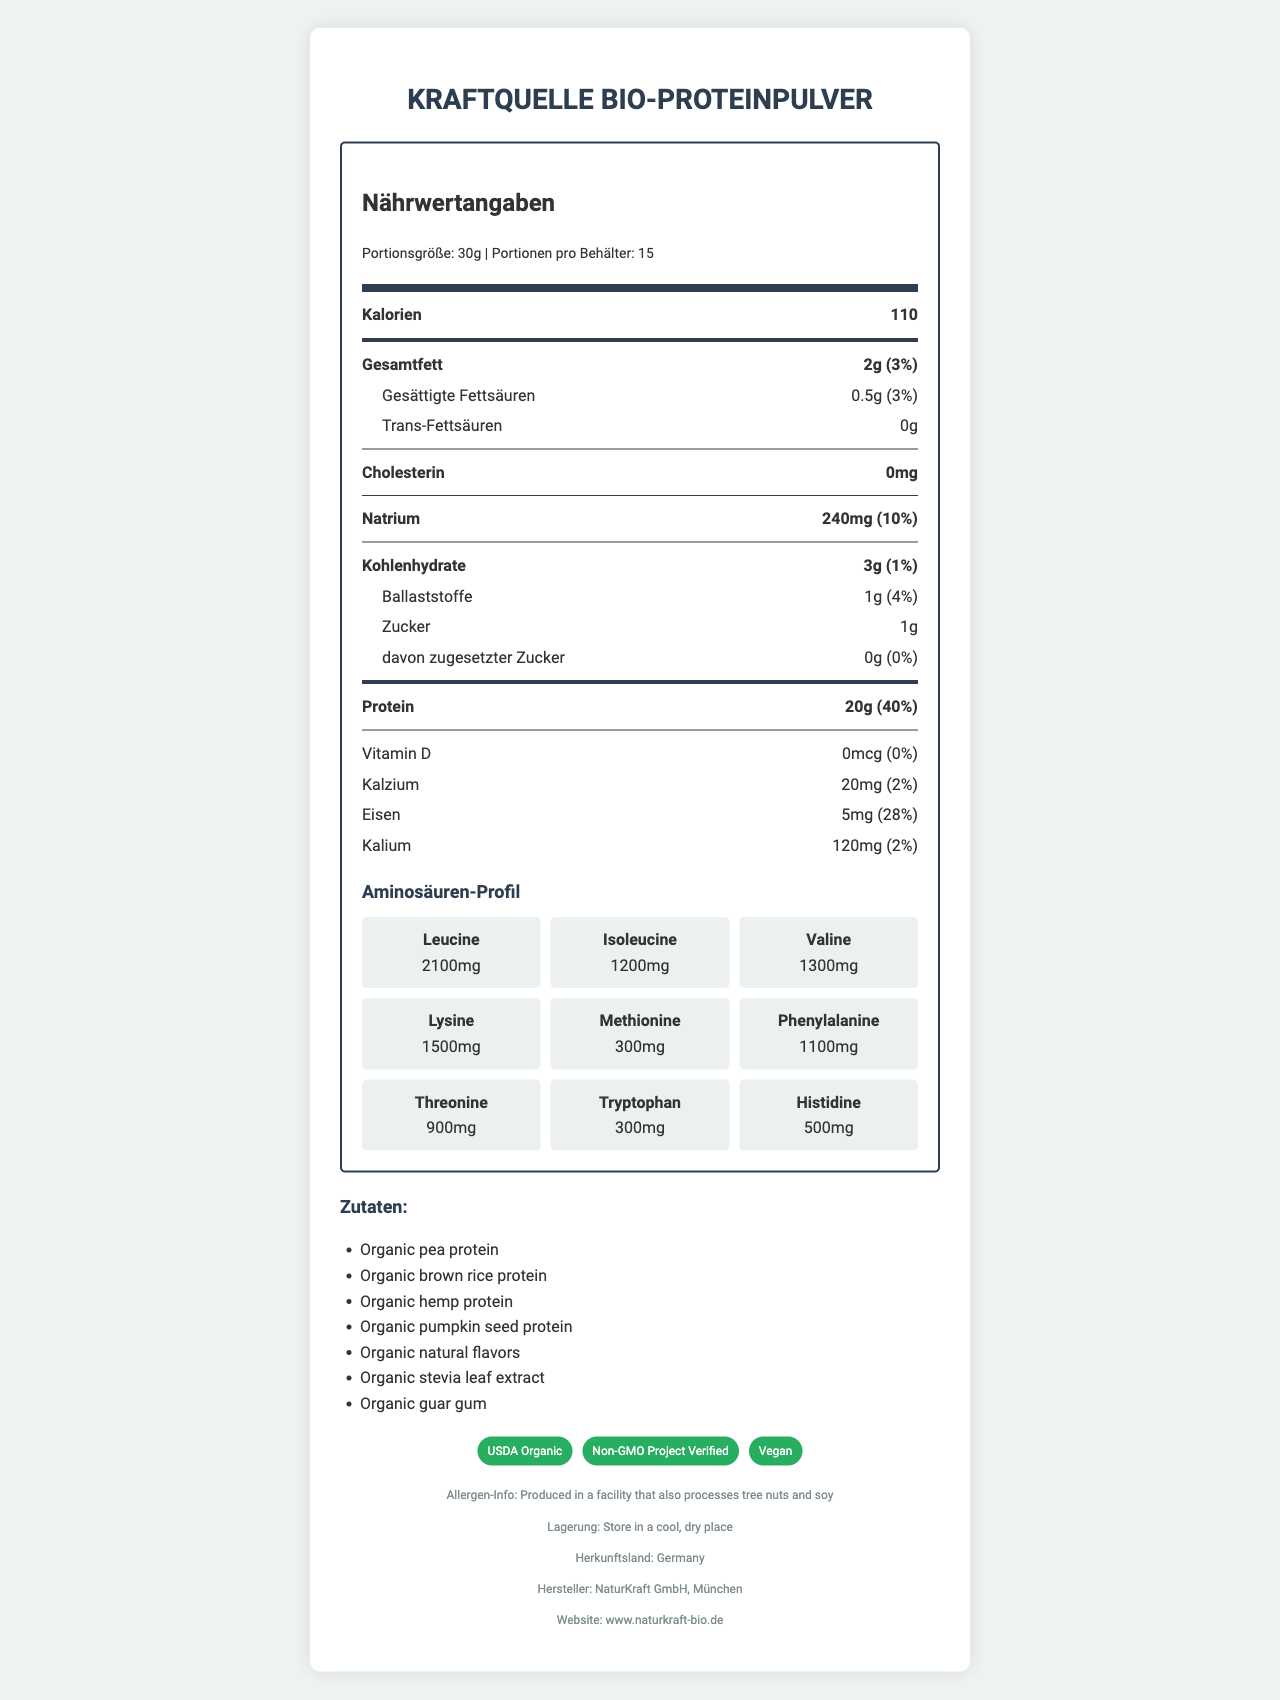what is the serving size? The serving size is listed as 30g at the top of the nutrition facts label.
Answer: 30g how many servings are in the container? The document specifies that there are 15 servings per container.
Answer: 15 how much iron does one serving provide? The iron content per serving is given as 5mg.
Answer: 5mg what is the percentage daily value (%DV) of iron per serving? The daily value percentage for iron is listed as 28%.
Answer: 28% list the main ingredients in this protein powder. The main ingredients are listed under the ingredients section.
Answer: Organic pea protein, Organic brown rice protein, Organic hemp protein, Organic pumpkin seed protein, Organic natural flavors, Organic stevia leaf extract, Organic guar gum which of the following amino acids has the highest content in the protein powder? A. Lysine B. Leucine C. Valine D. Methionine The amino acid profile shows leucine as having the highest content at 2100mg.
Answer: B how many grams of protein are in a serving? A. 10g B. 15g C. 20g D. 25g Each serving contains 20g of protein.
Answer: C is vitamin D present in this protein powder? The amount of Vitamin D is listed as 0mcg with a daily value percentage of 0%, indicating it is not present.
Answer: No does the product contain added sugars? The label shows that the amount of added sugars is 0g with a daily value percentage of 0%.
Answer: No hard name two certifications this product has received. Two certifications listed are USDA Organic and Non-GMO Project Verified.
Answer: USDA Organic, Non-GMO Project Verified where is this product manufactured? The manufacturer is listed as NaturKraft GmbH, München, which is in Germany.
Answer: München, Germany is this protein powder free from allergens? There is an allergen warning that it is produced in a facility that also processes tree nuts and soy.
Answer: No what percentage daily value of protein does each serving provide? Each serving provides 40% of the daily value for protein.
Answer: 40% describe the overall nutritional content of Kraftquelle Bio-Proteinpulver. The document outlines the nutritional facts, emphasizing protein content and an extensive amino acid profile while highlighting the low content of fats and carbohydrates. Certifications and ingredients are also listed, reflecting the product's organic and vegan nature.
Answer: This organic vegan protein powder contains a high amount of protein (20g per serving) with a comprehensive amino acid profile. It has minimal total fat (2g) and carbohydrates (3g), along with essential nutrients like iron (5mg, 28% DV). The product is free from cholesterol and added sugars. It is made from organic ingredients and has certifications like USDA Organic and Non-GMO Project Verified. what is the amino acid content of arginine in this product? The document does not list arginine in the amino acid profile; hence, its content cannot be determined.
Answer: Cannot be determined 